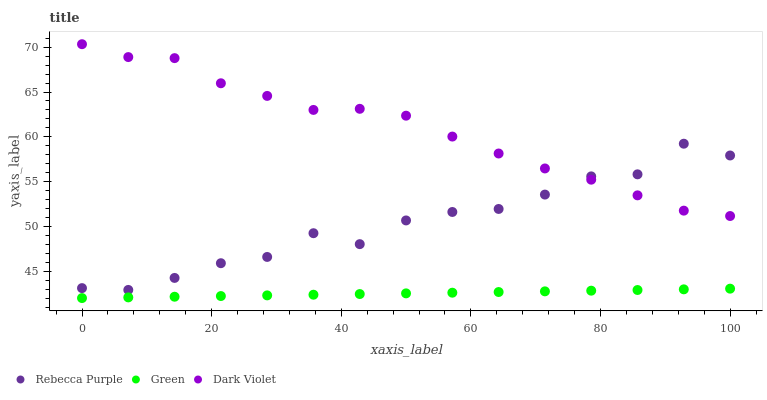Does Green have the minimum area under the curve?
Answer yes or no. Yes. Does Dark Violet have the maximum area under the curve?
Answer yes or no. Yes. Does Rebecca Purple have the minimum area under the curve?
Answer yes or no. No. Does Rebecca Purple have the maximum area under the curve?
Answer yes or no. No. Is Green the smoothest?
Answer yes or no. Yes. Is Rebecca Purple the roughest?
Answer yes or no. Yes. Is Dark Violet the smoothest?
Answer yes or no. No. Is Dark Violet the roughest?
Answer yes or no. No. Does Green have the lowest value?
Answer yes or no. Yes. Does Rebecca Purple have the lowest value?
Answer yes or no. No. Does Dark Violet have the highest value?
Answer yes or no. Yes. Does Rebecca Purple have the highest value?
Answer yes or no. No. Is Green less than Rebecca Purple?
Answer yes or no. Yes. Is Rebecca Purple greater than Green?
Answer yes or no. Yes. Does Rebecca Purple intersect Dark Violet?
Answer yes or no. Yes. Is Rebecca Purple less than Dark Violet?
Answer yes or no. No. Is Rebecca Purple greater than Dark Violet?
Answer yes or no. No. Does Green intersect Rebecca Purple?
Answer yes or no. No. 